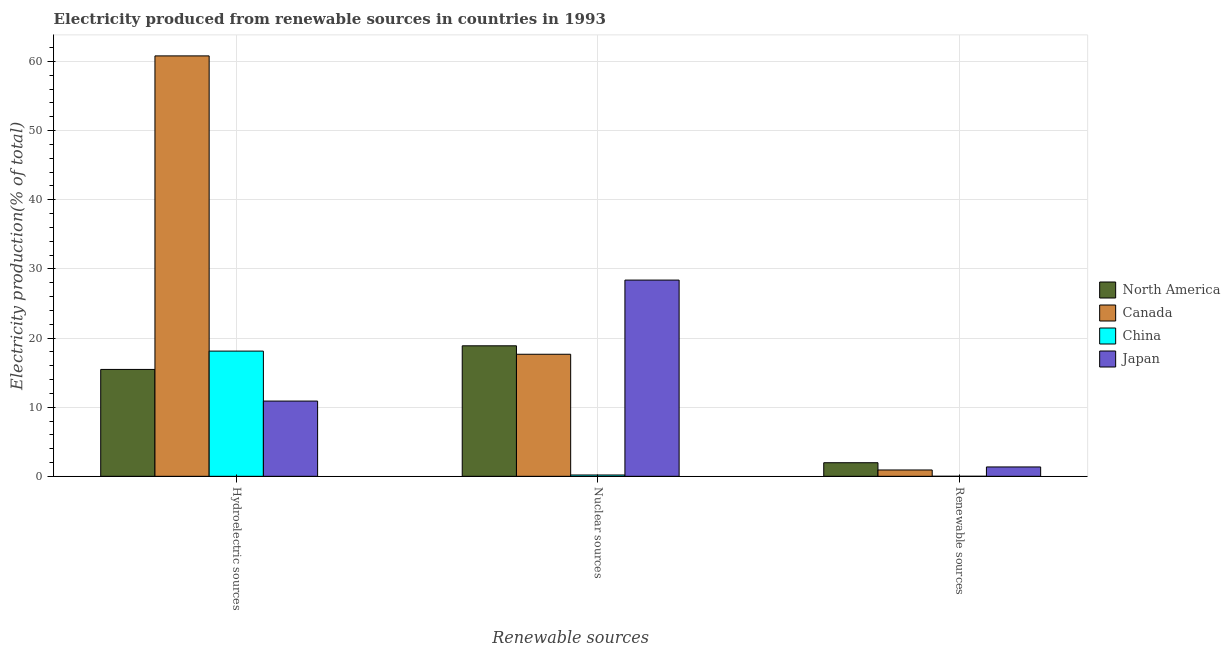How many different coloured bars are there?
Give a very brief answer. 4. How many bars are there on the 1st tick from the right?
Keep it short and to the point. 4. What is the label of the 2nd group of bars from the left?
Provide a succinct answer. Nuclear sources. What is the percentage of electricity produced by hydroelectric sources in North America?
Keep it short and to the point. 15.46. Across all countries, what is the maximum percentage of electricity produced by nuclear sources?
Your answer should be compact. 28.38. Across all countries, what is the minimum percentage of electricity produced by renewable sources?
Ensure brevity in your answer.  0. In which country was the percentage of electricity produced by nuclear sources maximum?
Your answer should be very brief. Japan. What is the total percentage of electricity produced by hydroelectric sources in the graph?
Your answer should be very brief. 105.26. What is the difference between the percentage of electricity produced by renewable sources in Japan and that in China?
Ensure brevity in your answer.  1.35. What is the difference between the percentage of electricity produced by hydroelectric sources in China and the percentage of electricity produced by nuclear sources in Japan?
Your response must be concise. -10.27. What is the average percentage of electricity produced by nuclear sources per country?
Ensure brevity in your answer.  16.28. What is the difference between the percentage of electricity produced by hydroelectric sources and percentage of electricity produced by renewable sources in China?
Offer a very short reply. 18.11. In how many countries, is the percentage of electricity produced by renewable sources greater than 12 %?
Make the answer very short. 0. What is the ratio of the percentage of electricity produced by renewable sources in Japan to that in North America?
Your response must be concise. 0.69. Is the percentage of electricity produced by nuclear sources in China less than that in Canada?
Keep it short and to the point. Yes. What is the difference between the highest and the second highest percentage of electricity produced by hydroelectric sources?
Provide a succinct answer. 42.69. What is the difference between the highest and the lowest percentage of electricity produced by nuclear sources?
Provide a short and direct response. 28.19. In how many countries, is the percentage of electricity produced by hydroelectric sources greater than the average percentage of electricity produced by hydroelectric sources taken over all countries?
Ensure brevity in your answer.  1. Is the sum of the percentage of electricity produced by nuclear sources in China and Canada greater than the maximum percentage of electricity produced by hydroelectric sources across all countries?
Offer a terse response. No. What does the 3rd bar from the left in Nuclear sources represents?
Provide a succinct answer. China. How many bars are there?
Provide a succinct answer. 12. How many countries are there in the graph?
Give a very brief answer. 4. Are the values on the major ticks of Y-axis written in scientific E-notation?
Your response must be concise. No. Does the graph contain grids?
Offer a terse response. Yes. How are the legend labels stacked?
Your answer should be very brief. Vertical. What is the title of the graph?
Your answer should be compact. Electricity produced from renewable sources in countries in 1993. Does "Turkmenistan" appear as one of the legend labels in the graph?
Offer a very short reply. No. What is the label or title of the X-axis?
Keep it short and to the point. Renewable sources. What is the label or title of the Y-axis?
Your answer should be compact. Electricity production(% of total). What is the Electricity production(% of total) of North America in Hydroelectric sources?
Your answer should be compact. 15.46. What is the Electricity production(% of total) in Canada in Hydroelectric sources?
Provide a short and direct response. 60.81. What is the Electricity production(% of total) of China in Hydroelectric sources?
Make the answer very short. 18.11. What is the Electricity production(% of total) of Japan in Hydroelectric sources?
Offer a terse response. 10.88. What is the Electricity production(% of total) of North America in Nuclear sources?
Make the answer very short. 18.88. What is the Electricity production(% of total) in Canada in Nuclear sources?
Offer a terse response. 17.65. What is the Electricity production(% of total) of China in Nuclear sources?
Your response must be concise. 0.19. What is the Electricity production(% of total) in Japan in Nuclear sources?
Give a very brief answer. 28.38. What is the Electricity production(% of total) of North America in Renewable sources?
Make the answer very short. 1.97. What is the Electricity production(% of total) in Canada in Renewable sources?
Your answer should be compact. 0.92. What is the Electricity production(% of total) in China in Renewable sources?
Keep it short and to the point. 0. What is the Electricity production(% of total) of Japan in Renewable sources?
Your response must be concise. 1.35. Across all Renewable sources, what is the maximum Electricity production(% of total) in North America?
Ensure brevity in your answer.  18.88. Across all Renewable sources, what is the maximum Electricity production(% of total) in Canada?
Your answer should be compact. 60.81. Across all Renewable sources, what is the maximum Electricity production(% of total) in China?
Ensure brevity in your answer.  18.11. Across all Renewable sources, what is the maximum Electricity production(% of total) in Japan?
Provide a short and direct response. 28.38. Across all Renewable sources, what is the minimum Electricity production(% of total) in North America?
Give a very brief answer. 1.97. Across all Renewable sources, what is the minimum Electricity production(% of total) of Canada?
Offer a very short reply. 0.92. Across all Renewable sources, what is the minimum Electricity production(% of total) in China?
Provide a succinct answer. 0. Across all Renewable sources, what is the minimum Electricity production(% of total) in Japan?
Make the answer very short. 1.35. What is the total Electricity production(% of total) in North America in the graph?
Your answer should be compact. 36.3. What is the total Electricity production(% of total) of Canada in the graph?
Give a very brief answer. 79.38. What is the total Electricity production(% of total) in China in the graph?
Give a very brief answer. 18.31. What is the total Electricity production(% of total) in Japan in the graph?
Your response must be concise. 40.62. What is the difference between the Electricity production(% of total) in North America in Hydroelectric sources and that in Nuclear sources?
Ensure brevity in your answer.  -3.42. What is the difference between the Electricity production(% of total) of Canada in Hydroelectric sources and that in Nuclear sources?
Your answer should be very brief. 43.15. What is the difference between the Electricity production(% of total) in China in Hydroelectric sources and that in Nuclear sources?
Your answer should be very brief. 17.92. What is the difference between the Electricity production(% of total) in Japan in Hydroelectric sources and that in Nuclear sources?
Keep it short and to the point. -17.5. What is the difference between the Electricity production(% of total) in North America in Hydroelectric sources and that in Renewable sources?
Give a very brief answer. 13.49. What is the difference between the Electricity production(% of total) of Canada in Hydroelectric sources and that in Renewable sources?
Offer a very short reply. 59.89. What is the difference between the Electricity production(% of total) of China in Hydroelectric sources and that in Renewable sources?
Provide a succinct answer. 18.11. What is the difference between the Electricity production(% of total) of Japan in Hydroelectric sources and that in Renewable sources?
Provide a succinct answer. 9.53. What is the difference between the Electricity production(% of total) in North America in Nuclear sources and that in Renewable sources?
Make the answer very short. 16.91. What is the difference between the Electricity production(% of total) of Canada in Nuclear sources and that in Renewable sources?
Your answer should be very brief. 16.74. What is the difference between the Electricity production(% of total) in China in Nuclear sources and that in Renewable sources?
Make the answer very short. 0.19. What is the difference between the Electricity production(% of total) of Japan in Nuclear sources and that in Renewable sources?
Offer a very short reply. 27.03. What is the difference between the Electricity production(% of total) of North America in Hydroelectric sources and the Electricity production(% of total) of Canada in Nuclear sources?
Offer a terse response. -2.19. What is the difference between the Electricity production(% of total) of North America in Hydroelectric sources and the Electricity production(% of total) of China in Nuclear sources?
Give a very brief answer. 15.27. What is the difference between the Electricity production(% of total) of North America in Hydroelectric sources and the Electricity production(% of total) of Japan in Nuclear sources?
Your answer should be compact. -12.92. What is the difference between the Electricity production(% of total) of Canada in Hydroelectric sources and the Electricity production(% of total) of China in Nuclear sources?
Provide a short and direct response. 60.61. What is the difference between the Electricity production(% of total) in Canada in Hydroelectric sources and the Electricity production(% of total) in Japan in Nuclear sources?
Your answer should be very brief. 32.43. What is the difference between the Electricity production(% of total) in China in Hydroelectric sources and the Electricity production(% of total) in Japan in Nuclear sources?
Provide a succinct answer. -10.27. What is the difference between the Electricity production(% of total) of North America in Hydroelectric sources and the Electricity production(% of total) of Canada in Renewable sources?
Offer a very short reply. 14.54. What is the difference between the Electricity production(% of total) in North America in Hydroelectric sources and the Electricity production(% of total) in China in Renewable sources?
Your answer should be compact. 15.46. What is the difference between the Electricity production(% of total) of North America in Hydroelectric sources and the Electricity production(% of total) of Japan in Renewable sources?
Keep it short and to the point. 14.11. What is the difference between the Electricity production(% of total) of Canada in Hydroelectric sources and the Electricity production(% of total) of China in Renewable sources?
Keep it short and to the point. 60.8. What is the difference between the Electricity production(% of total) in Canada in Hydroelectric sources and the Electricity production(% of total) in Japan in Renewable sources?
Offer a very short reply. 59.45. What is the difference between the Electricity production(% of total) of China in Hydroelectric sources and the Electricity production(% of total) of Japan in Renewable sources?
Your answer should be very brief. 16.76. What is the difference between the Electricity production(% of total) in North America in Nuclear sources and the Electricity production(% of total) in Canada in Renewable sources?
Give a very brief answer. 17.96. What is the difference between the Electricity production(% of total) of North America in Nuclear sources and the Electricity production(% of total) of China in Renewable sources?
Give a very brief answer. 18.87. What is the difference between the Electricity production(% of total) in North America in Nuclear sources and the Electricity production(% of total) in Japan in Renewable sources?
Offer a terse response. 17.52. What is the difference between the Electricity production(% of total) in Canada in Nuclear sources and the Electricity production(% of total) in China in Renewable sources?
Your response must be concise. 17.65. What is the difference between the Electricity production(% of total) of Canada in Nuclear sources and the Electricity production(% of total) of Japan in Renewable sources?
Offer a terse response. 16.3. What is the difference between the Electricity production(% of total) of China in Nuclear sources and the Electricity production(% of total) of Japan in Renewable sources?
Your answer should be very brief. -1.16. What is the average Electricity production(% of total) of North America per Renewable sources?
Offer a very short reply. 12.1. What is the average Electricity production(% of total) in Canada per Renewable sources?
Ensure brevity in your answer.  26.46. What is the average Electricity production(% of total) of China per Renewable sources?
Make the answer very short. 6.1. What is the average Electricity production(% of total) in Japan per Renewable sources?
Your response must be concise. 13.54. What is the difference between the Electricity production(% of total) of North America and Electricity production(% of total) of Canada in Hydroelectric sources?
Your answer should be compact. -45.35. What is the difference between the Electricity production(% of total) of North America and Electricity production(% of total) of China in Hydroelectric sources?
Your answer should be very brief. -2.65. What is the difference between the Electricity production(% of total) in North America and Electricity production(% of total) in Japan in Hydroelectric sources?
Keep it short and to the point. 4.58. What is the difference between the Electricity production(% of total) in Canada and Electricity production(% of total) in China in Hydroelectric sources?
Offer a terse response. 42.69. What is the difference between the Electricity production(% of total) of Canada and Electricity production(% of total) of Japan in Hydroelectric sources?
Offer a terse response. 49.92. What is the difference between the Electricity production(% of total) of China and Electricity production(% of total) of Japan in Hydroelectric sources?
Your response must be concise. 7.23. What is the difference between the Electricity production(% of total) of North America and Electricity production(% of total) of Canada in Nuclear sources?
Offer a terse response. 1.22. What is the difference between the Electricity production(% of total) of North America and Electricity production(% of total) of China in Nuclear sources?
Offer a very short reply. 18.68. What is the difference between the Electricity production(% of total) in North America and Electricity production(% of total) in Japan in Nuclear sources?
Keep it short and to the point. -9.5. What is the difference between the Electricity production(% of total) of Canada and Electricity production(% of total) of China in Nuclear sources?
Ensure brevity in your answer.  17.46. What is the difference between the Electricity production(% of total) in Canada and Electricity production(% of total) in Japan in Nuclear sources?
Keep it short and to the point. -10.73. What is the difference between the Electricity production(% of total) of China and Electricity production(% of total) of Japan in Nuclear sources?
Keep it short and to the point. -28.19. What is the difference between the Electricity production(% of total) of North America and Electricity production(% of total) of Canada in Renewable sources?
Ensure brevity in your answer.  1.05. What is the difference between the Electricity production(% of total) of North America and Electricity production(% of total) of China in Renewable sources?
Make the answer very short. 1.96. What is the difference between the Electricity production(% of total) of North America and Electricity production(% of total) of Japan in Renewable sources?
Offer a very short reply. 0.61. What is the difference between the Electricity production(% of total) of Canada and Electricity production(% of total) of China in Renewable sources?
Your response must be concise. 0.91. What is the difference between the Electricity production(% of total) of Canada and Electricity production(% of total) of Japan in Renewable sources?
Give a very brief answer. -0.44. What is the difference between the Electricity production(% of total) of China and Electricity production(% of total) of Japan in Renewable sources?
Provide a succinct answer. -1.35. What is the ratio of the Electricity production(% of total) of North America in Hydroelectric sources to that in Nuclear sources?
Provide a succinct answer. 0.82. What is the ratio of the Electricity production(% of total) of Canada in Hydroelectric sources to that in Nuclear sources?
Give a very brief answer. 3.44. What is the ratio of the Electricity production(% of total) in China in Hydroelectric sources to that in Nuclear sources?
Ensure brevity in your answer.  94.65. What is the ratio of the Electricity production(% of total) of Japan in Hydroelectric sources to that in Nuclear sources?
Provide a short and direct response. 0.38. What is the ratio of the Electricity production(% of total) of North America in Hydroelectric sources to that in Renewable sources?
Offer a very short reply. 7.87. What is the ratio of the Electricity production(% of total) of Canada in Hydroelectric sources to that in Renewable sources?
Provide a short and direct response. 66.32. What is the ratio of the Electricity production(% of total) in China in Hydroelectric sources to that in Renewable sources?
Provide a succinct answer. 5839.19. What is the ratio of the Electricity production(% of total) in Japan in Hydroelectric sources to that in Renewable sources?
Make the answer very short. 8.04. What is the ratio of the Electricity production(% of total) of North America in Nuclear sources to that in Renewable sources?
Give a very brief answer. 9.6. What is the ratio of the Electricity production(% of total) of Canada in Nuclear sources to that in Renewable sources?
Provide a short and direct response. 19.25. What is the ratio of the Electricity production(% of total) in China in Nuclear sources to that in Renewable sources?
Ensure brevity in your answer.  61.69. What is the ratio of the Electricity production(% of total) in Japan in Nuclear sources to that in Renewable sources?
Offer a very short reply. 20.95. What is the difference between the highest and the second highest Electricity production(% of total) in North America?
Your response must be concise. 3.42. What is the difference between the highest and the second highest Electricity production(% of total) of Canada?
Make the answer very short. 43.15. What is the difference between the highest and the second highest Electricity production(% of total) in China?
Provide a short and direct response. 17.92. What is the difference between the highest and the second highest Electricity production(% of total) in Japan?
Give a very brief answer. 17.5. What is the difference between the highest and the lowest Electricity production(% of total) in North America?
Your response must be concise. 16.91. What is the difference between the highest and the lowest Electricity production(% of total) of Canada?
Give a very brief answer. 59.89. What is the difference between the highest and the lowest Electricity production(% of total) in China?
Make the answer very short. 18.11. What is the difference between the highest and the lowest Electricity production(% of total) of Japan?
Ensure brevity in your answer.  27.03. 